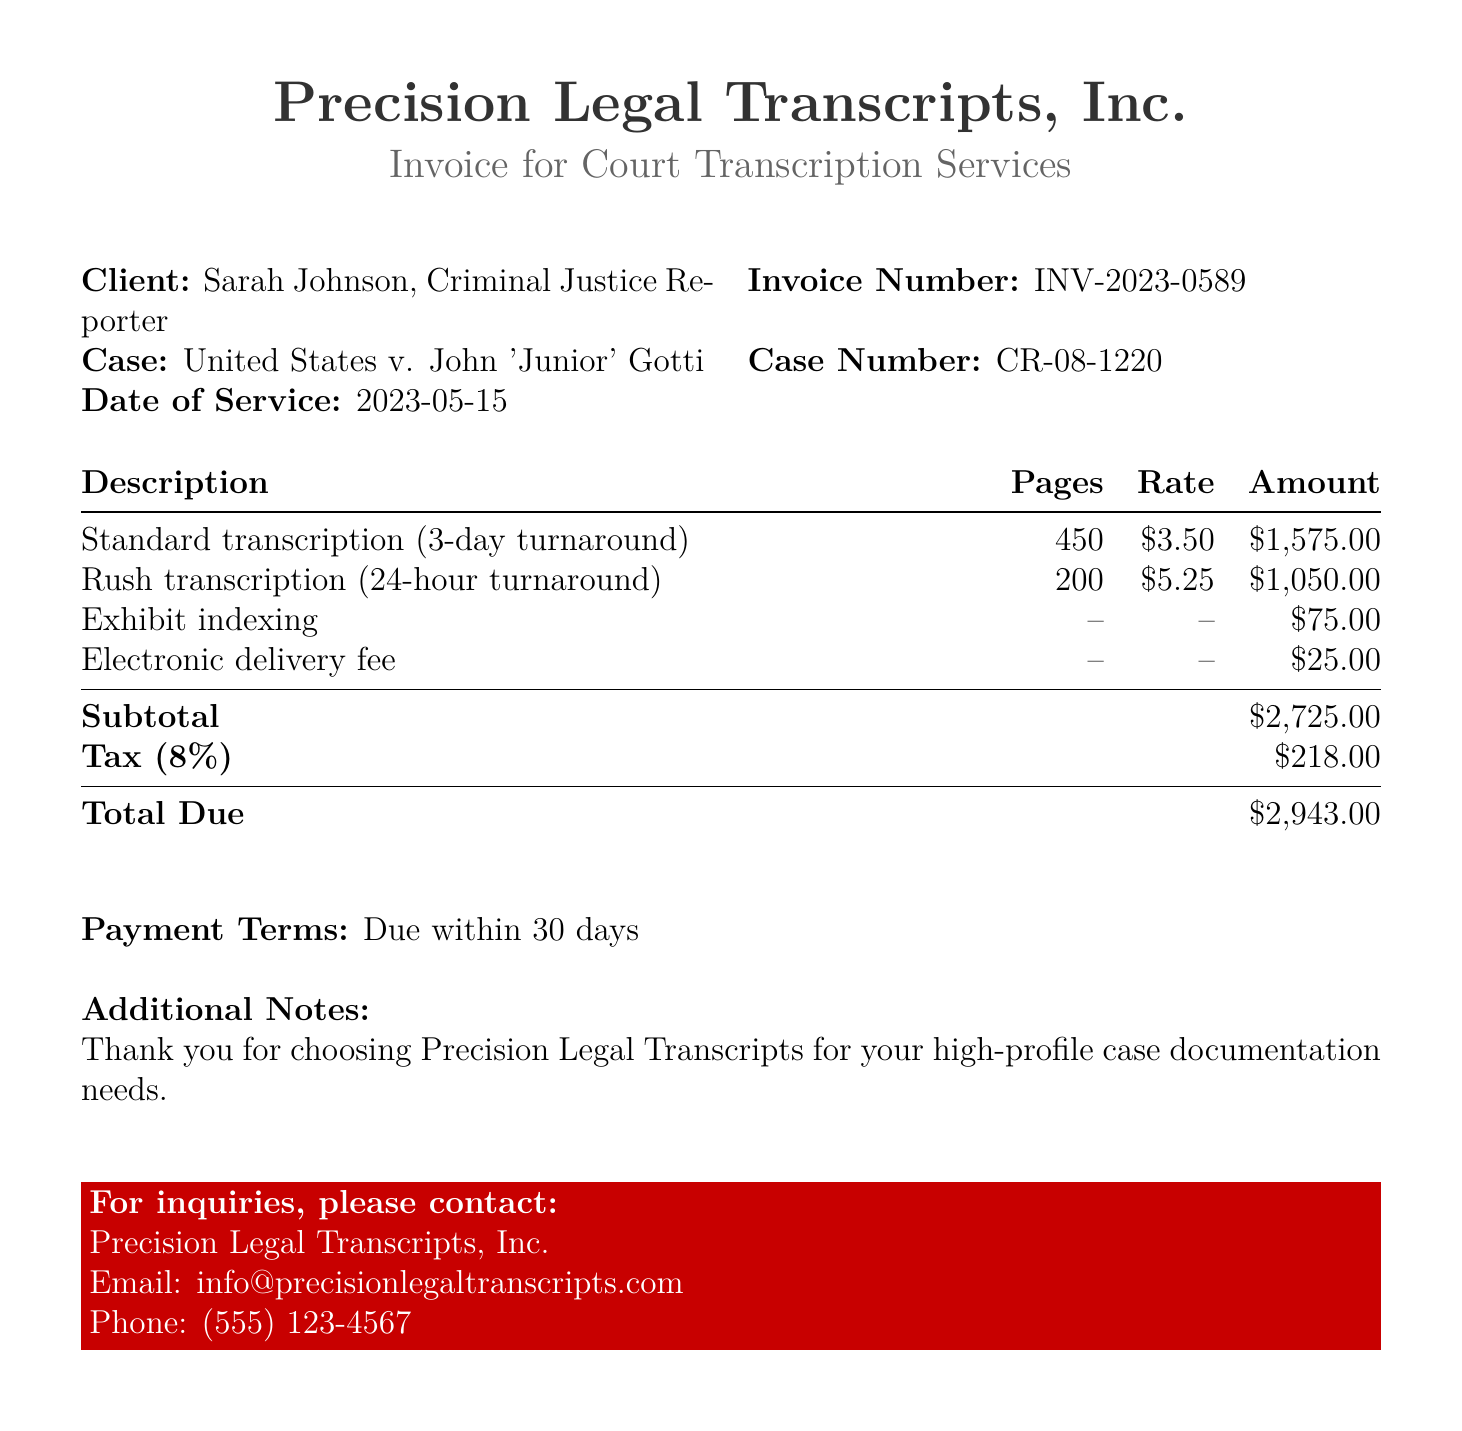What is the client’s name? The client's name is mentioned in the header section of the document.
Answer: Sarah Johnson How many pages were transcribed for rush service? The rush transcription pages are specified in the amount charged for service in the document.
Answer: 200 What is the rate per page for standard transcription? The document explicitly states the rate for standard transcription in the pricing table.
Answer: $3.50 What is the total due amount? The total due is clearly outlined at the bottom of the bill.
Answer: $2,943.00 What is the tax percentage applied to the subtotal? The tax percentage is stated in the section detailing tax calculations in the document.
Answer: 8% What is the subtotal amount before tax? The subtotal amount can be found in the itemized section of costs listed in the document.
Answer: $2,725.00 What type of delivery fee is included in the invoice? The delivery type is specified in the breakdown of services rendered in the document.
Answer: Electronic delivery fee What is the date of service provided? The date of service is mentioned in the header section of the document.
Answer: 2023-05-15 What is the purpose of exhibit indexing? The purpose of exhibit indexing is indicated in the description of the charges for service.
Answer: Indexing exhibits 